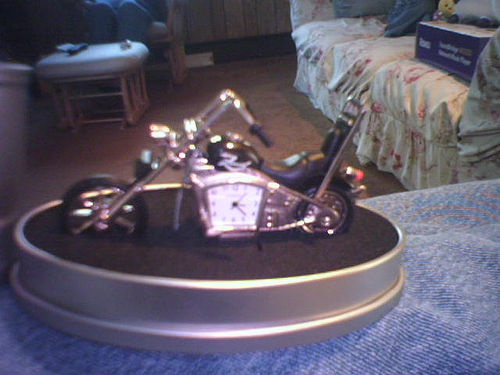Describe the objects in this image and their specific colors. I can see bed in black, gray, darkgray, and navy tones, couch in black, gray, and darkgray tones, motorcycle in black, gray, and lavender tones, people in black and gray tones, and people in black, navy, darkblue, and blue tones in this image. 